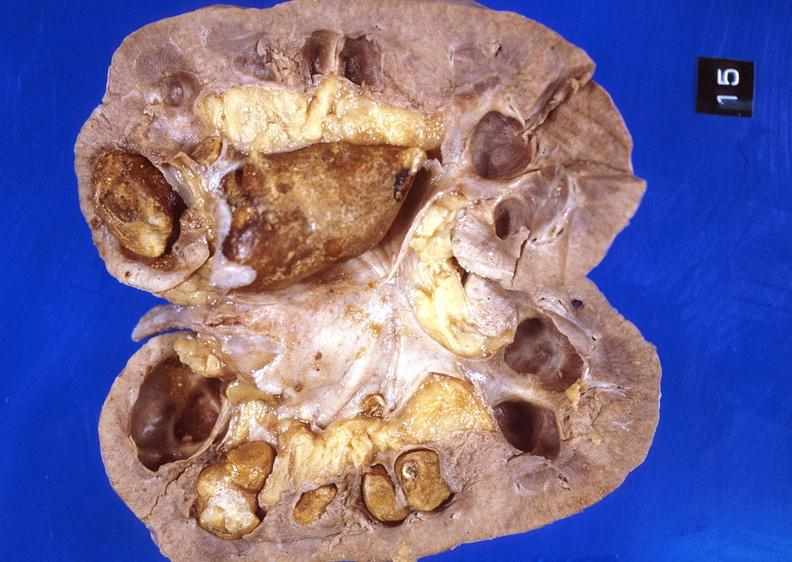where is this?
Answer the question using a single word or phrase. Urinary 